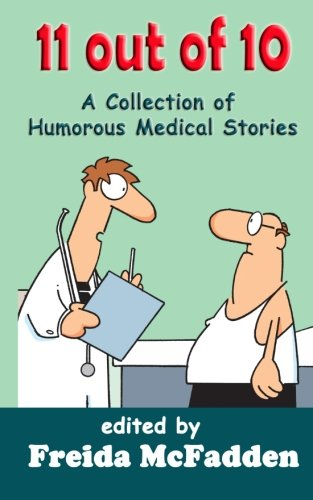Is this a pharmaceutical book? No, this book is not pharmaceutical. Instead, it offers a collection of humorous tales centered around medical situations, designed to entertain and amuse its readers. 